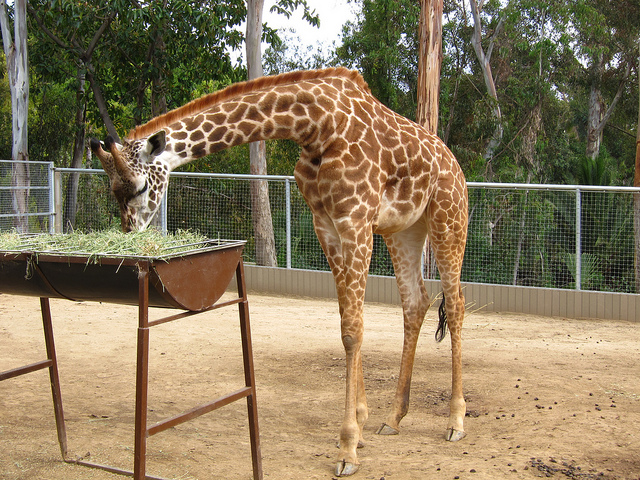How many zoo creatures? 1 